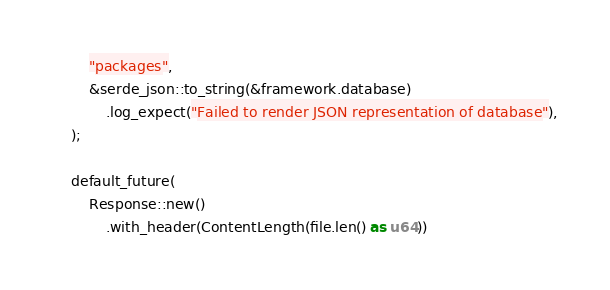<code> <loc_0><loc_0><loc_500><loc_500><_Rust_>        "packages",
        &serde_json::to_string(&framework.database)
            .log_expect("Failed to render JSON representation of database"),
    );

    default_future(
        Response::new()
            .with_header(ContentLength(file.len() as u64))</code> 